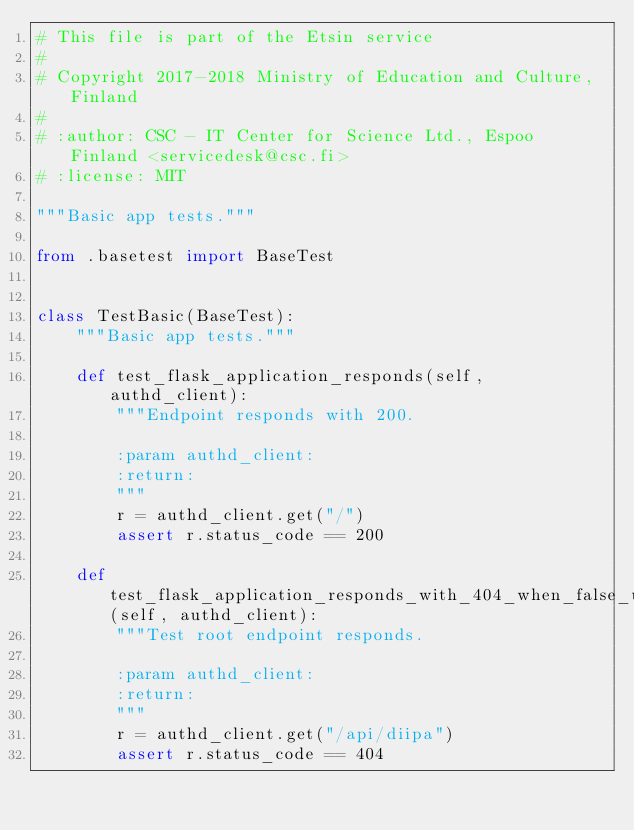<code> <loc_0><loc_0><loc_500><loc_500><_Python_># This file is part of the Etsin service
#
# Copyright 2017-2018 Ministry of Education and Culture, Finland
#
# :author: CSC - IT Center for Science Ltd., Espoo Finland <servicedesk@csc.fi>
# :license: MIT

"""Basic app tests."""

from .basetest import BaseTest


class TestBasic(BaseTest):
    """Basic app tests."""

    def test_flask_application_responds(self, authd_client):
        """Endpoint responds with 200.

        :param authd_client:
        :return:
        """
        r = authd_client.get("/")
        assert r.status_code == 200

    def test_flask_application_responds_with_404_when_false_url(self, authd_client):
        """Test root endpoint responds.

        :param authd_client:
        :return:
        """
        r = authd_client.get("/api/diipa")
        assert r.status_code == 404
</code> 